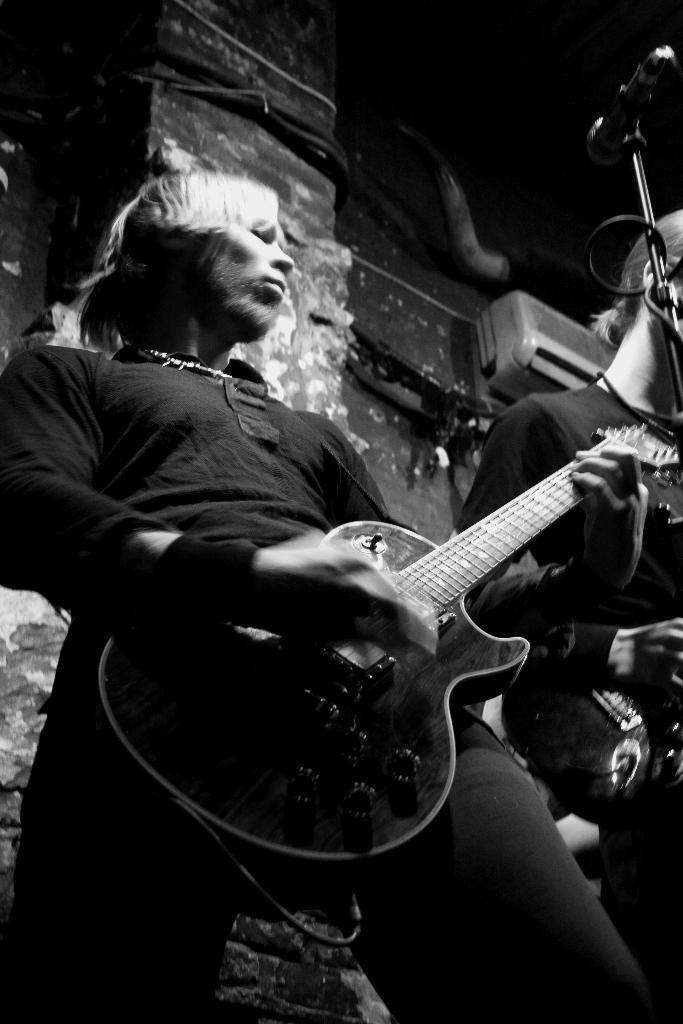What is the person in the image doing with the guitar? The person is playing the guitar. Can you describe the person's activity in the image? The person is holding a guitar and playing it. Who else is present in the image? There is another person standing nearby. What can be seen in the background of the image? There is a wall and an air conditioning unit (AC) in the background of the image. How would you describe the lighting in the image? The background is dark. What type of apparel is the carriage wearing in the image? There is no carriage present in the image, so it is not possible to answer that question. 